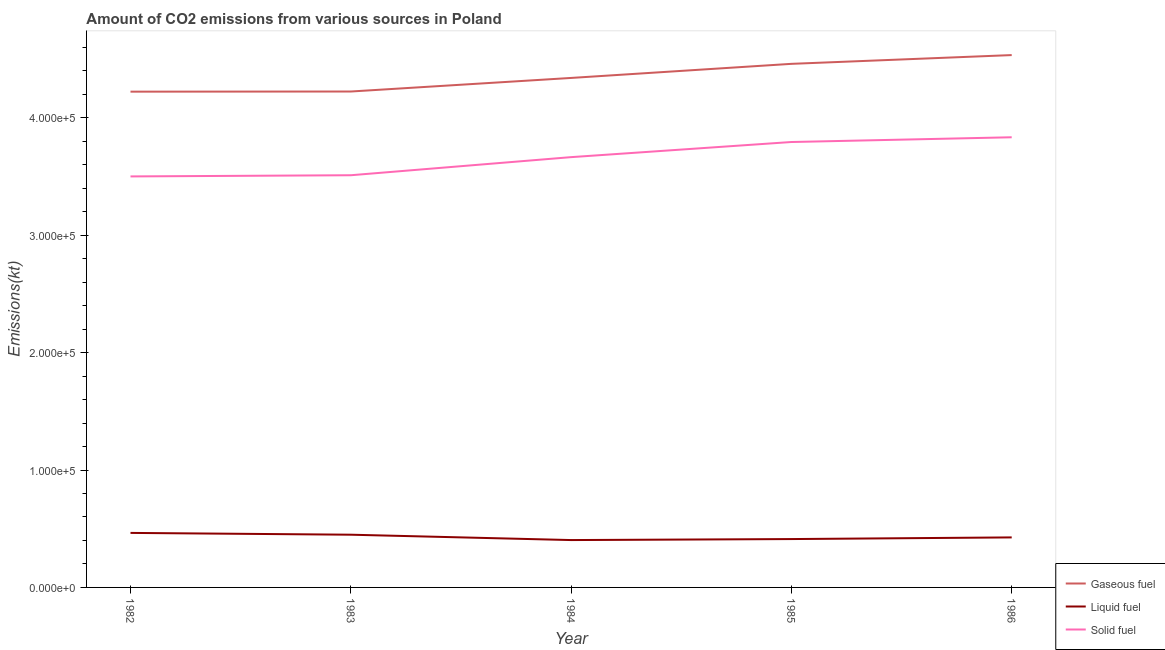Is the number of lines equal to the number of legend labels?
Ensure brevity in your answer.  Yes. What is the amount of co2 emissions from gaseous fuel in 1985?
Give a very brief answer. 4.46e+05. Across all years, what is the maximum amount of co2 emissions from liquid fuel?
Ensure brevity in your answer.  4.64e+04. Across all years, what is the minimum amount of co2 emissions from gaseous fuel?
Your answer should be compact. 4.22e+05. What is the total amount of co2 emissions from liquid fuel in the graph?
Your answer should be compact. 2.15e+05. What is the difference between the amount of co2 emissions from solid fuel in 1983 and that in 1985?
Offer a terse response. -2.83e+04. What is the difference between the amount of co2 emissions from solid fuel in 1983 and the amount of co2 emissions from gaseous fuel in 1986?
Offer a terse response. -1.02e+05. What is the average amount of co2 emissions from liquid fuel per year?
Provide a short and direct response. 4.31e+04. In the year 1984, what is the difference between the amount of co2 emissions from gaseous fuel and amount of co2 emissions from liquid fuel?
Provide a short and direct response. 3.94e+05. What is the ratio of the amount of co2 emissions from gaseous fuel in 1983 to that in 1986?
Your response must be concise. 0.93. Is the amount of co2 emissions from solid fuel in 1982 less than that in 1986?
Your answer should be compact. Yes. Is the difference between the amount of co2 emissions from gaseous fuel in 1982 and 1986 greater than the difference between the amount of co2 emissions from liquid fuel in 1982 and 1986?
Offer a terse response. No. What is the difference between the highest and the second highest amount of co2 emissions from solid fuel?
Provide a short and direct response. 4044.7. What is the difference between the highest and the lowest amount of co2 emissions from gaseous fuel?
Your answer should be very brief. 3.12e+04. In how many years, is the amount of co2 emissions from liquid fuel greater than the average amount of co2 emissions from liquid fuel taken over all years?
Give a very brief answer. 2. Does the amount of co2 emissions from solid fuel monotonically increase over the years?
Your response must be concise. Yes. Is the amount of co2 emissions from gaseous fuel strictly greater than the amount of co2 emissions from solid fuel over the years?
Your answer should be compact. Yes. How many lines are there?
Ensure brevity in your answer.  3. How many years are there in the graph?
Your answer should be compact. 5. Does the graph contain grids?
Make the answer very short. No. What is the title of the graph?
Give a very brief answer. Amount of CO2 emissions from various sources in Poland. What is the label or title of the X-axis?
Your answer should be compact. Year. What is the label or title of the Y-axis?
Make the answer very short. Emissions(kt). What is the Emissions(kt) in Gaseous fuel in 1982?
Offer a terse response. 4.22e+05. What is the Emissions(kt) in Liquid fuel in 1982?
Keep it short and to the point. 4.64e+04. What is the Emissions(kt) of Solid fuel in 1982?
Ensure brevity in your answer.  3.50e+05. What is the Emissions(kt) in Gaseous fuel in 1983?
Provide a succinct answer. 4.22e+05. What is the Emissions(kt) in Liquid fuel in 1983?
Offer a terse response. 4.49e+04. What is the Emissions(kt) in Solid fuel in 1983?
Offer a terse response. 3.51e+05. What is the Emissions(kt) in Gaseous fuel in 1984?
Offer a terse response. 4.34e+05. What is the Emissions(kt) of Liquid fuel in 1984?
Keep it short and to the point. 4.03e+04. What is the Emissions(kt) in Solid fuel in 1984?
Your answer should be very brief. 3.66e+05. What is the Emissions(kt) in Gaseous fuel in 1985?
Provide a succinct answer. 4.46e+05. What is the Emissions(kt) in Liquid fuel in 1985?
Your response must be concise. 4.12e+04. What is the Emissions(kt) in Solid fuel in 1985?
Your answer should be compact. 3.79e+05. What is the Emissions(kt) in Gaseous fuel in 1986?
Offer a terse response. 4.53e+05. What is the Emissions(kt) in Liquid fuel in 1986?
Make the answer very short. 4.26e+04. What is the Emissions(kt) in Solid fuel in 1986?
Your response must be concise. 3.83e+05. Across all years, what is the maximum Emissions(kt) of Gaseous fuel?
Offer a terse response. 4.53e+05. Across all years, what is the maximum Emissions(kt) in Liquid fuel?
Offer a very short reply. 4.64e+04. Across all years, what is the maximum Emissions(kt) in Solid fuel?
Offer a terse response. 3.83e+05. Across all years, what is the minimum Emissions(kt) in Gaseous fuel?
Ensure brevity in your answer.  4.22e+05. Across all years, what is the minimum Emissions(kt) in Liquid fuel?
Give a very brief answer. 4.03e+04. Across all years, what is the minimum Emissions(kt) of Solid fuel?
Keep it short and to the point. 3.50e+05. What is the total Emissions(kt) in Gaseous fuel in the graph?
Your answer should be compact. 2.18e+06. What is the total Emissions(kt) of Liquid fuel in the graph?
Offer a terse response. 2.15e+05. What is the total Emissions(kt) of Solid fuel in the graph?
Your answer should be very brief. 1.83e+06. What is the difference between the Emissions(kt) in Gaseous fuel in 1982 and that in 1983?
Your answer should be very brief. -128.34. What is the difference between the Emissions(kt) of Liquid fuel in 1982 and that in 1983?
Provide a short and direct response. 1529.14. What is the difference between the Emissions(kt) in Solid fuel in 1982 and that in 1983?
Offer a very short reply. -1008.42. What is the difference between the Emissions(kt) of Gaseous fuel in 1982 and that in 1984?
Keep it short and to the point. -1.17e+04. What is the difference between the Emissions(kt) of Liquid fuel in 1982 and that in 1984?
Offer a terse response. 6094.55. What is the difference between the Emissions(kt) in Solid fuel in 1982 and that in 1984?
Offer a terse response. -1.64e+04. What is the difference between the Emissions(kt) of Gaseous fuel in 1982 and that in 1985?
Your response must be concise. -2.37e+04. What is the difference between the Emissions(kt) of Liquid fuel in 1982 and that in 1985?
Your response must be concise. 5243.81. What is the difference between the Emissions(kt) of Solid fuel in 1982 and that in 1985?
Make the answer very short. -2.93e+04. What is the difference between the Emissions(kt) of Gaseous fuel in 1982 and that in 1986?
Your answer should be compact. -3.12e+04. What is the difference between the Emissions(kt) of Liquid fuel in 1982 and that in 1986?
Ensure brevity in your answer.  3832.01. What is the difference between the Emissions(kt) of Solid fuel in 1982 and that in 1986?
Your response must be concise. -3.34e+04. What is the difference between the Emissions(kt) of Gaseous fuel in 1983 and that in 1984?
Give a very brief answer. -1.16e+04. What is the difference between the Emissions(kt) in Liquid fuel in 1983 and that in 1984?
Provide a succinct answer. 4565.41. What is the difference between the Emissions(kt) of Solid fuel in 1983 and that in 1984?
Ensure brevity in your answer.  -1.54e+04. What is the difference between the Emissions(kt) of Gaseous fuel in 1983 and that in 1985?
Keep it short and to the point. -2.36e+04. What is the difference between the Emissions(kt) in Liquid fuel in 1983 and that in 1985?
Ensure brevity in your answer.  3714.67. What is the difference between the Emissions(kt) in Solid fuel in 1983 and that in 1985?
Provide a succinct answer. -2.83e+04. What is the difference between the Emissions(kt) in Gaseous fuel in 1983 and that in 1986?
Offer a terse response. -3.10e+04. What is the difference between the Emissions(kt) of Liquid fuel in 1983 and that in 1986?
Provide a short and direct response. 2302.88. What is the difference between the Emissions(kt) of Solid fuel in 1983 and that in 1986?
Offer a terse response. -3.23e+04. What is the difference between the Emissions(kt) in Gaseous fuel in 1984 and that in 1985?
Your answer should be very brief. -1.20e+04. What is the difference between the Emissions(kt) in Liquid fuel in 1984 and that in 1985?
Make the answer very short. -850.74. What is the difference between the Emissions(kt) in Solid fuel in 1984 and that in 1985?
Ensure brevity in your answer.  -1.29e+04. What is the difference between the Emissions(kt) in Gaseous fuel in 1984 and that in 1986?
Provide a succinct answer. -1.95e+04. What is the difference between the Emissions(kt) in Liquid fuel in 1984 and that in 1986?
Offer a very short reply. -2262.54. What is the difference between the Emissions(kt) in Solid fuel in 1984 and that in 1986?
Offer a very short reply. -1.69e+04. What is the difference between the Emissions(kt) in Gaseous fuel in 1985 and that in 1986?
Your answer should be very brief. -7469.68. What is the difference between the Emissions(kt) in Liquid fuel in 1985 and that in 1986?
Your answer should be very brief. -1411.8. What is the difference between the Emissions(kt) of Solid fuel in 1985 and that in 1986?
Offer a terse response. -4044.7. What is the difference between the Emissions(kt) of Gaseous fuel in 1982 and the Emissions(kt) of Liquid fuel in 1983?
Keep it short and to the point. 3.77e+05. What is the difference between the Emissions(kt) in Gaseous fuel in 1982 and the Emissions(kt) in Solid fuel in 1983?
Your response must be concise. 7.12e+04. What is the difference between the Emissions(kt) in Liquid fuel in 1982 and the Emissions(kt) in Solid fuel in 1983?
Offer a very short reply. -3.05e+05. What is the difference between the Emissions(kt) of Gaseous fuel in 1982 and the Emissions(kt) of Liquid fuel in 1984?
Ensure brevity in your answer.  3.82e+05. What is the difference between the Emissions(kt) in Gaseous fuel in 1982 and the Emissions(kt) in Solid fuel in 1984?
Provide a succinct answer. 5.58e+04. What is the difference between the Emissions(kt) of Liquid fuel in 1982 and the Emissions(kt) of Solid fuel in 1984?
Make the answer very short. -3.20e+05. What is the difference between the Emissions(kt) of Gaseous fuel in 1982 and the Emissions(kt) of Liquid fuel in 1985?
Your response must be concise. 3.81e+05. What is the difference between the Emissions(kt) of Gaseous fuel in 1982 and the Emissions(kt) of Solid fuel in 1985?
Make the answer very short. 4.29e+04. What is the difference between the Emissions(kt) of Liquid fuel in 1982 and the Emissions(kt) of Solid fuel in 1985?
Offer a terse response. -3.33e+05. What is the difference between the Emissions(kt) in Gaseous fuel in 1982 and the Emissions(kt) in Liquid fuel in 1986?
Ensure brevity in your answer.  3.80e+05. What is the difference between the Emissions(kt) in Gaseous fuel in 1982 and the Emissions(kt) in Solid fuel in 1986?
Your response must be concise. 3.88e+04. What is the difference between the Emissions(kt) in Liquid fuel in 1982 and the Emissions(kt) in Solid fuel in 1986?
Your answer should be very brief. -3.37e+05. What is the difference between the Emissions(kt) of Gaseous fuel in 1983 and the Emissions(kt) of Liquid fuel in 1984?
Your answer should be very brief. 3.82e+05. What is the difference between the Emissions(kt) of Gaseous fuel in 1983 and the Emissions(kt) of Solid fuel in 1984?
Provide a short and direct response. 5.59e+04. What is the difference between the Emissions(kt) in Liquid fuel in 1983 and the Emissions(kt) in Solid fuel in 1984?
Your answer should be very brief. -3.22e+05. What is the difference between the Emissions(kt) of Gaseous fuel in 1983 and the Emissions(kt) of Liquid fuel in 1985?
Provide a succinct answer. 3.81e+05. What is the difference between the Emissions(kt) in Gaseous fuel in 1983 and the Emissions(kt) in Solid fuel in 1985?
Give a very brief answer. 4.30e+04. What is the difference between the Emissions(kt) in Liquid fuel in 1983 and the Emissions(kt) in Solid fuel in 1985?
Your answer should be very brief. -3.34e+05. What is the difference between the Emissions(kt) of Gaseous fuel in 1983 and the Emissions(kt) of Liquid fuel in 1986?
Ensure brevity in your answer.  3.80e+05. What is the difference between the Emissions(kt) of Gaseous fuel in 1983 and the Emissions(kt) of Solid fuel in 1986?
Give a very brief answer. 3.90e+04. What is the difference between the Emissions(kt) in Liquid fuel in 1983 and the Emissions(kt) in Solid fuel in 1986?
Offer a very short reply. -3.38e+05. What is the difference between the Emissions(kt) in Gaseous fuel in 1984 and the Emissions(kt) in Liquid fuel in 1985?
Ensure brevity in your answer.  3.93e+05. What is the difference between the Emissions(kt) of Gaseous fuel in 1984 and the Emissions(kt) of Solid fuel in 1985?
Keep it short and to the point. 5.46e+04. What is the difference between the Emissions(kt) in Liquid fuel in 1984 and the Emissions(kt) in Solid fuel in 1985?
Your answer should be very brief. -3.39e+05. What is the difference between the Emissions(kt) in Gaseous fuel in 1984 and the Emissions(kt) in Liquid fuel in 1986?
Offer a terse response. 3.91e+05. What is the difference between the Emissions(kt) in Gaseous fuel in 1984 and the Emissions(kt) in Solid fuel in 1986?
Your answer should be very brief. 5.05e+04. What is the difference between the Emissions(kt) in Liquid fuel in 1984 and the Emissions(kt) in Solid fuel in 1986?
Make the answer very short. -3.43e+05. What is the difference between the Emissions(kt) of Gaseous fuel in 1985 and the Emissions(kt) of Liquid fuel in 1986?
Provide a short and direct response. 4.03e+05. What is the difference between the Emissions(kt) in Gaseous fuel in 1985 and the Emissions(kt) in Solid fuel in 1986?
Keep it short and to the point. 6.25e+04. What is the difference between the Emissions(kt) of Liquid fuel in 1985 and the Emissions(kt) of Solid fuel in 1986?
Provide a succinct answer. -3.42e+05. What is the average Emissions(kt) of Gaseous fuel per year?
Ensure brevity in your answer.  4.36e+05. What is the average Emissions(kt) in Liquid fuel per year?
Your answer should be very brief. 4.31e+04. What is the average Emissions(kt) in Solid fuel per year?
Keep it short and to the point. 3.66e+05. In the year 1982, what is the difference between the Emissions(kt) in Gaseous fuel and Emissions(kt) in Liquid fuel?
Your answer should be very brief. 3.76e+05. In the year 1982, what is the difference between the Emissions(kt) in Gaseous fuel and Emissions(kt) in Solid fuel?
Give a very brief answer. 7.22e+04. In the year 1982, what is the difference between the Emissions(kt) in Liquid fuel and Emissions(kt) in Solid fuel?
Keep it short and to the point. -3.04e+05. In the year 1983, what is the difference between the Emissions(kt) of Gaseous fuel and Emissions(kt) of Liquid fuel?
Offer a terse response. 3.77e+05. In the year 1983, what is the difference between the Emissions(kt) in Gaseous fuel and Emissions(kt) in Solid fuel?
Your response must be concise. 7.13e+04. In the year 1983, what is the difference between the Emissions(kt) of Liquid fuel and Emissions(kt) of Solid fuel?
Make the answer very short. -3.06e+05. In the year 1984, what is the difference between the Emissions(kt) in Gaseous fuel and Emissions(kt) in Liquid fuel?
Offer a very short reply. 3.94e+05. In the year 1984, what is the difference between the Emissions(kt) of Gaseous fuel and Emissions(kt) of Solid fuel?
Your response must be concise. 6.74e+04. In the year 1984, what is the difference between the Emissions(kt) in Liquid fuel and Emissions(kt) in Solid fuel?
Make the answer very short. -3.26e+05. In the year 1985, what is the difference between the Emissions(kt) in Gaseous fuel and Emissions(kt) in Liquid fuel?
Provide a short and direct response. 4.05e+05. In the year 1985, what is the difference between the Emissions(kt) of Gaseous fuel and Emissions(kt) of Solid fuel?
Offer a terse response. 6.66e+04. In the year 1985, what is the difference between the Emissions(kt) of Liquid fuel and Emissions(kt) of Solid fuel?
Offer a terse response. -3.38e+05. In the year 1986, what is the difference between the Emissions(kt) in Gaseous fuel and Emissions(kt) in Liquid fuel?
Keep it short and to the point. 4.11e+05. In the year 1986, what is the difference between the Emissions(kt) in Gaseous fuel and Emissions(kt) in Solid fuel?
Offer a very short reply. 7.00e+04. In the year 1986, what is the difference between the Emissions(kt) in Liquid fuel and Emissions(kt) in Solid fuel?
Make the answer very short. -3.41e+05. What is the ratio of the Emissions(kt) in Gaseous fuel in 1982 to that in 1983?
Make the answer very short. 1. What is the ratio of the Emissions(kt) in Liquid fuel in 1982 to that in 1983?
Your response must be concise. 1.03. What is the ratio of the Emissions(kt) in Solid fuel in 1982 to that in 1983?
Provide a succinct answer. 1. What is the ratio of the Emissions(kt) of Gaseous fuel in 1982 to that in 1984?
Provide a succinct answer. 0.97. What is the ratio of the Emissions(kt) of Liquid fuel in 1982 to that in 1984?
Offer a very short reply. 1.15. What is the ratio of the Emissions(kt) in Solid fuel in 1982 to that in 1984?
Make the answer very short. 0.96. What is the ratio of the Emissions(kt) of Gaseous fuel in 1982 to that in 1985?
Provide a succinct answer. 0.95. What is the ratio of the Emissions(kt) in Liquid fuel in 1982 to that in 1985?
Offer a very short reply. 1.13. What is the ratio of the Emissions(kt) of Solid fuel in 1982 to that in 1985?
Make the answer very short. 0.92. What is the ratio of the Emissions(kt) in Gaseous fuel in 1982 to that in 1986?
Your response must be concise. 0.93. What is the ratio of the Emissions(kt) in Liquid fuel in 1982 to that in 1986?
Your response must be concise. 1.09. What is the ratio of the Emissions(kt) in Solid fuel in 1982 to that in 1986?
Ensure brevity in your answer.  0.91. What is the ratio of the Emissions(kt) of Gaseous fuel in 1983 to that in 1984?
Give a very brief answer. 0.97. What is the ratio of the Emissions(kt) of Liquid fuel in 1983 to that in 1984?
Give a very brief answer. 1.11. What is the ratio of the Emissions(kt) in Solid fuel in 1983 to that in 1984?
Provide a short and direct response. 0.96. What is the ratio of the Emissions(kt) of Gaseous fuel in 1983 to that in 1985?
Offer a very short reply. 0.95. What is the ratio of the Emissions(kt) of Liquid fuel in 1983 to that in 1985?
Your response must be concise. 1.09. What is the ratio of the Emissions(kt) of Solid fuel in 1983 to that in 1985?
Provide a short and direct response. 0.93. What is the ratio of the Emissions(kt) of Gaseous fuel in 1983 to that in 1986?
Offer a very short reply. 0.93. What is the ratio of the Emissions(kt) in Liquid fuel in 1983 to that in 1986?
Ensure brevity in your answer.  1.05. What is the ratio of the Emissions(kt) of Solid fuel in 1983 to that in 1986?
Your response must be concise. 0.92. What is the ratio of the Emissions(kt) of Gaseous fuel in 1984 to that in 1985?
Your response must be concise. 0.97. What is the ratio of the Emissions(kt) of Liquid fuel in 1984 to that in 1985?
Keep it short and to the point. 0.98. What is the ratio of the Emissions(kt) in Solid fuel in 1984 to that in 1985?
Give a very brief answer. 0.97. What is the ratio of the Emissions(kt) in Liquid fuel in 1984 to that in 1986?
Make the answer very short. 0.95. What is the ratio of the Emissions(kt) in Solid fuel in 1984 to that in 1986?
Your response must be concise. 0.96. What is the ratio of the Emissions(kt) of Gaseous fuel in 1985 to that in 1986?
Provide a succinct answer. 0.98. What is the ratio of the Emissions(kt) of Liquid fuel in 1985 to that in 1986?
Ensure brevity in your answer.  0.97. What is the ratio of the Emissions(kt) in Solid fuel in 1985 to that in 1986?
Your answer should be compact. 0.99. What is the difference between the highest and the second highest Emissions(kt) of Gaseous fuel?
Offer a terse response. 7469.68. What is the difference between the highest and the second highest Emissions(kt) in Liquid fuel?
Your answer should be compact. 1529.14. What is the difference between the highest and the second highest Emissions(kt) of Solid fuel?
Provide a short and direct response. 4044.7. What is the difference between the highest and the lowest Emissions(kt) in Gaseous fuel?
Provide a succinct answer. 3.12e+04. What is the difference between the highest and the lowest Emissions(kt) of Liquid fuel?
Your answer should be compact. 6094.55. What is the difference between the highest and the lowest Emissions(kt) of Solid fuel?
Your answer should be very brief. 3.34e+04. 